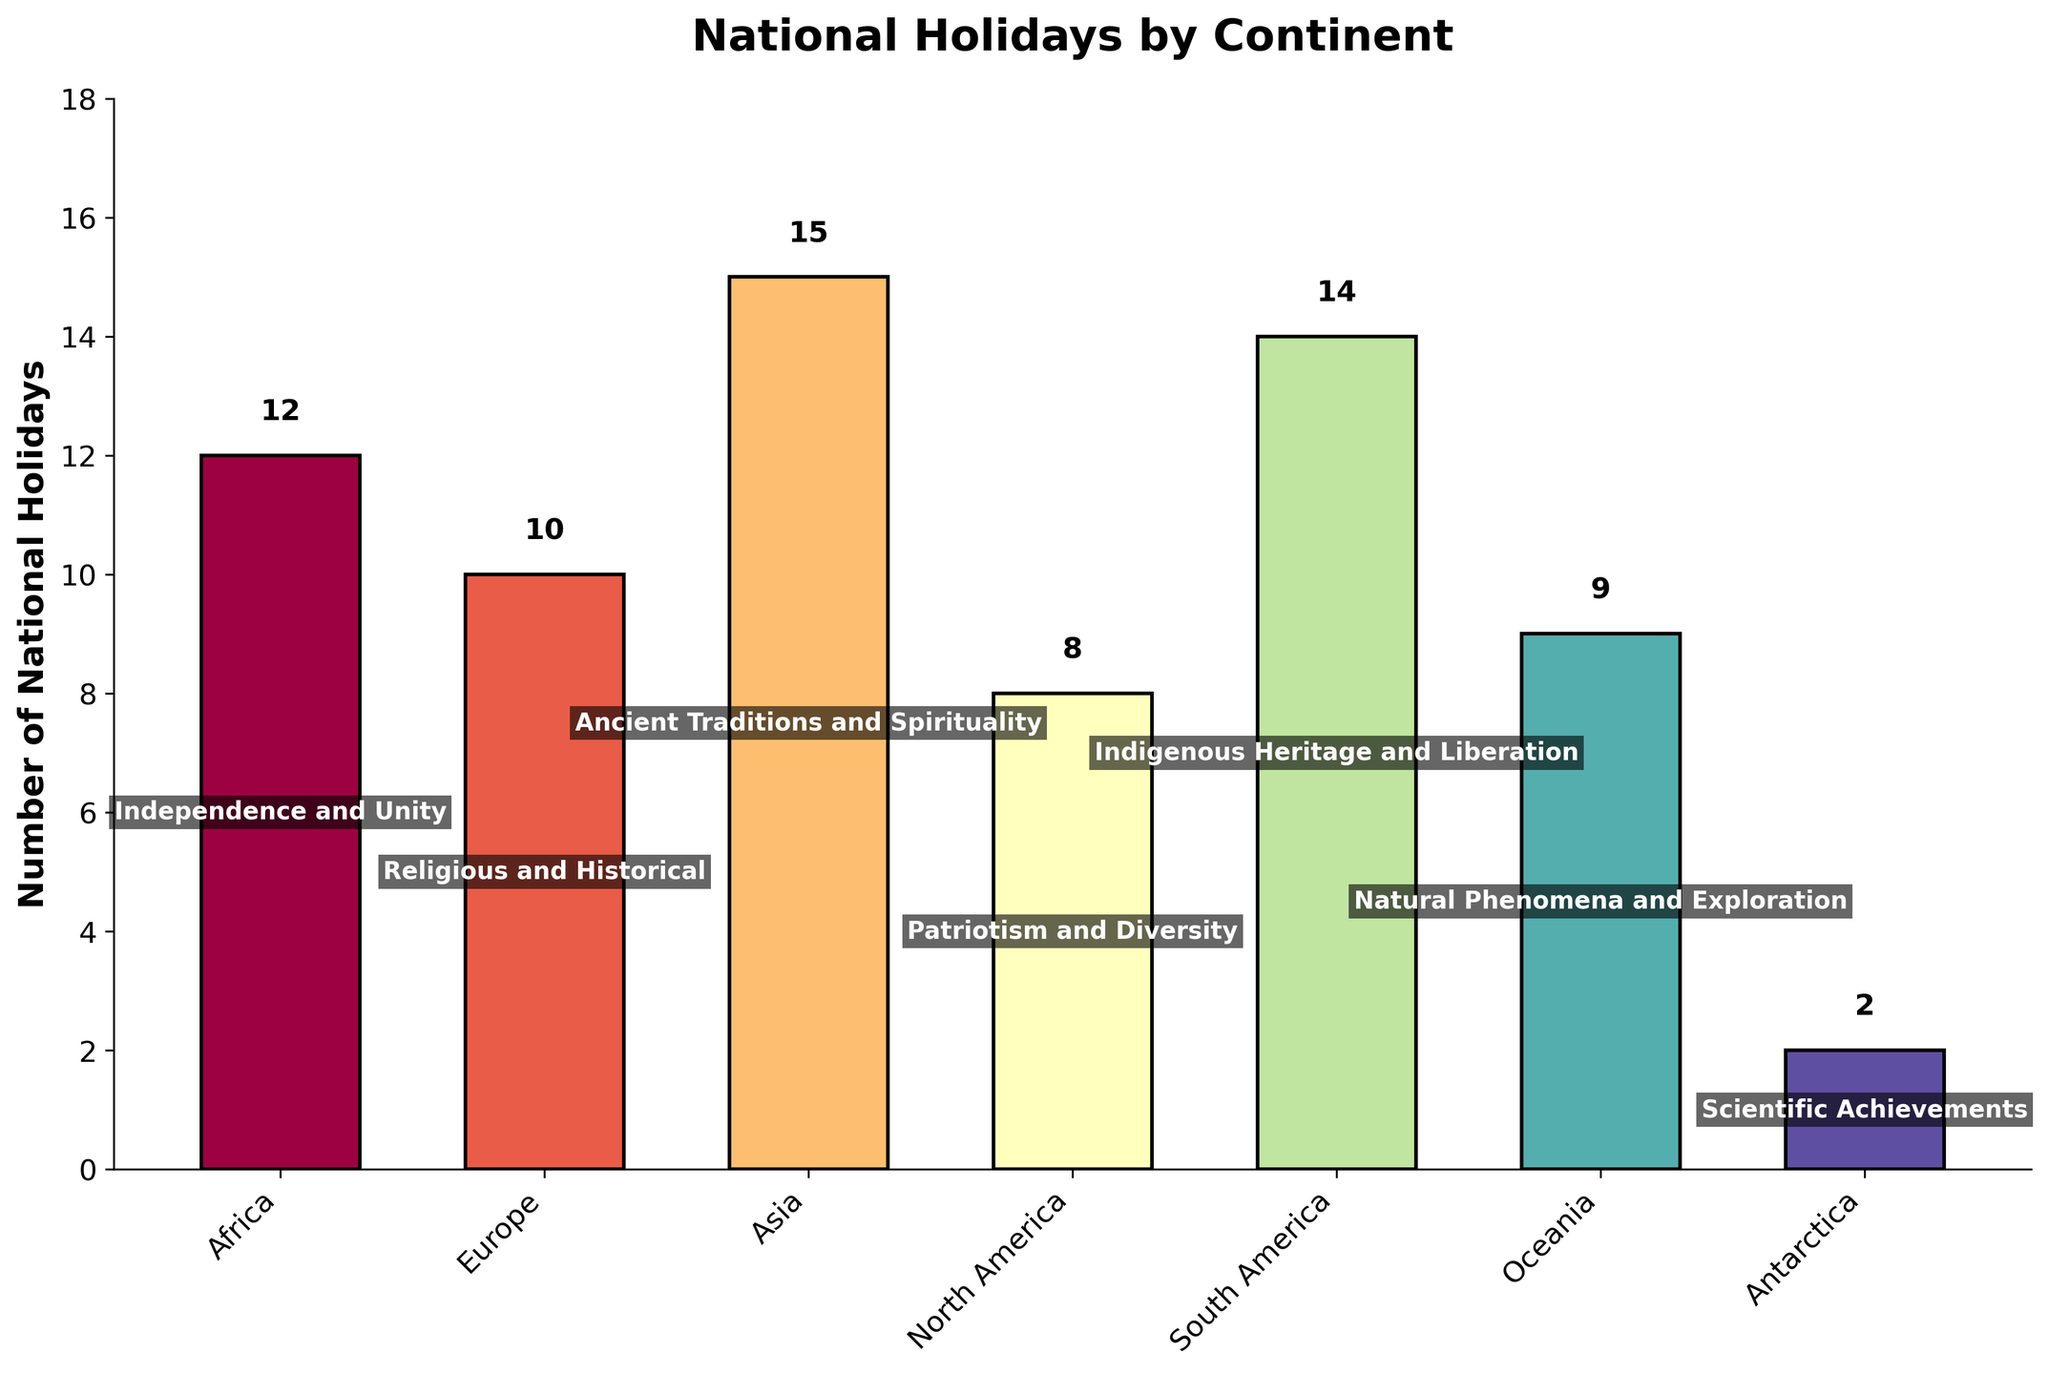How many more national holidays does Asia have compared to North America? Asia has 15 national holidays, and North America has 8. The difference is calculated by subtracting North America's count from Asia's: 15 - 8 = 7.
Answer: 7 Which continent has the fewest national holidays? Antarctica has the fewest national holidays, indicated by the shortest bar, with a count of 2.
Answer: Antarctica What is the most common primary cultural theme in South America? The primary cultural theme is indicated in the middle of the bar for South America, which reads "Indigenous Heritage and Liberation".
Answer: Indigenous Heritage and Liberation How many national holidays are there in total across all continents? Sum the number of national holidays for each continent: 12 (Africa) + 10 (Europe) + 15 (Asia) + 8 (North America) + 14 (South America) + 9 (Oceania) + 2 (Antarctica). The sum is 70.
Answer: 70 What are the primary cultural themes in the continents with fewer than 10 national holidays each? Continents with fewer than 10 national holidays are Europe (10), North America (8), Oceania (9), and Antarctica (2). Their themes are indicated in the bars as follows: Europe - "Religious and Historical", North America - "Patriotism and Diversity", Oceania - "Natural Phenomena and Exploration", and Antarctica - "Scientific Achievements".
Answer: Religious and Historical, Patriotism and Diversity, Natural Phenomena and Exploration, Scientific Achievements Which two continents have the closest number of national holidays? Europe has 10 national holidays, and Oceania has 9 national holidays. The difference is 1, which is the smallest difference compared to other pairs of continents.
Answer: Europe and Oceania Is the number of national holidays in Africa greater than the number in Oceania? Africa has 12 national holidays, while Oceania has 9. Since 12 is greater than 9, the answer is yes.
Answer: Yes What is the average number of national holidays across the continents listed? To find the average, sum the number of national holidays then divide by the number of continents: (12 + 10 + 15 + 8 + 14 + 9 + 2) / 7. The total is 70, and 70 divided by 7 equals 10.
Answer: 10 What is the primary cultural theme of the continent with the highest number of national holidays? Asia has the highest number of national holidays, which is 15. The primary cultural theme for Asia, indicated in the bar, is “Ancient Traditions and Spirituality”.
Answer: Ancient Traditions and Spirituality 